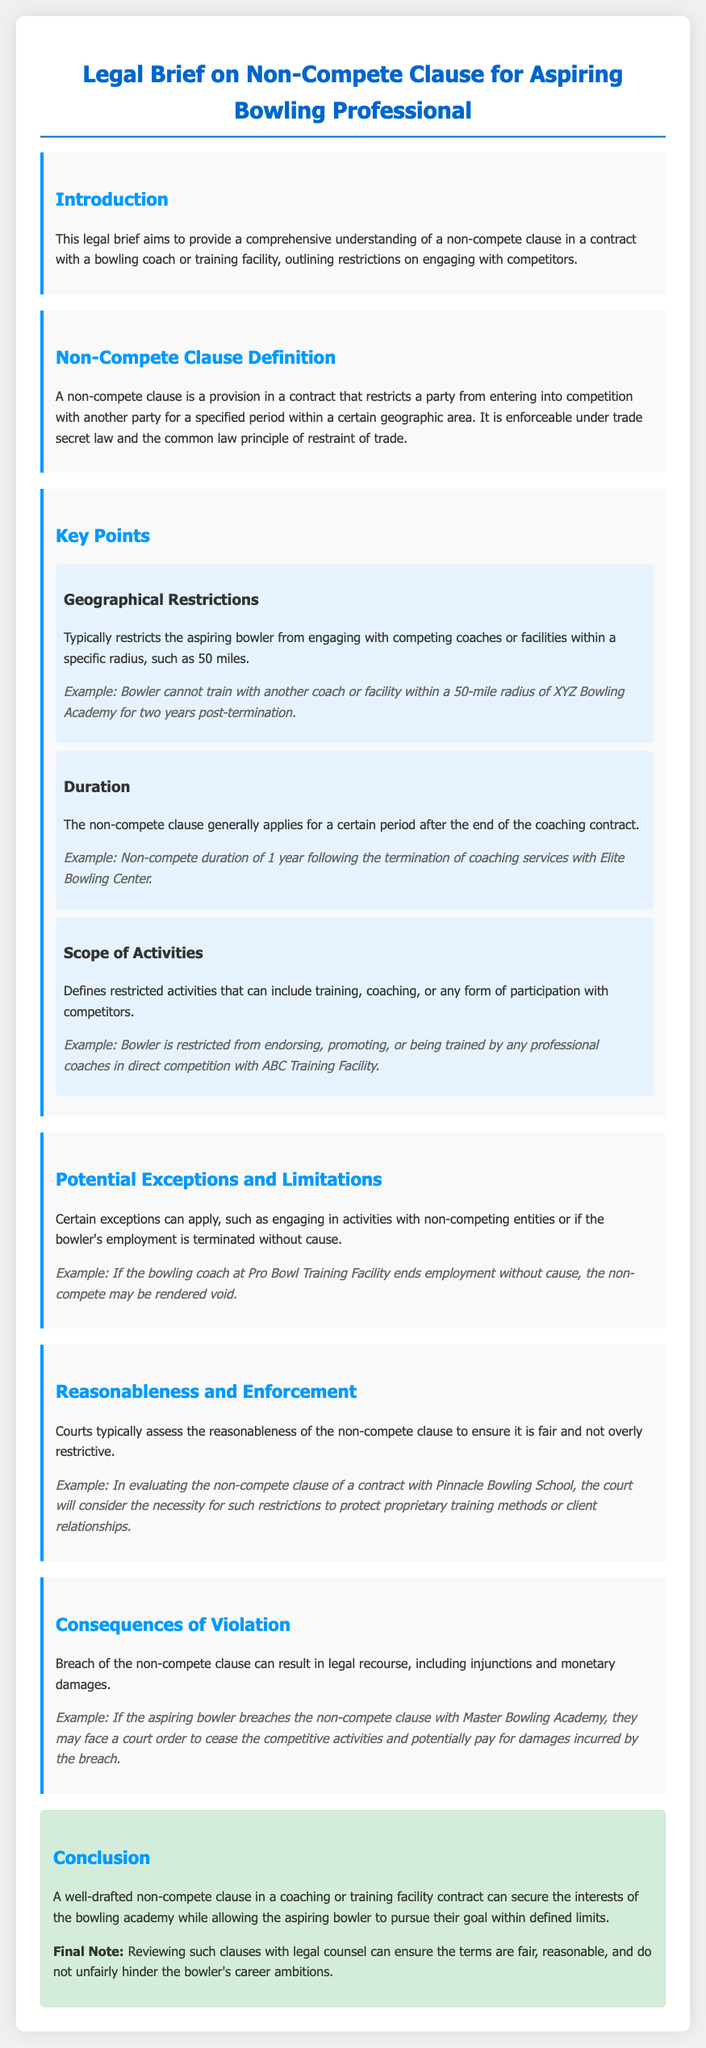What is a non-compete clause? A non-compete clause is a provision in a contract that restricts a party from entering into competition with another party for a specified period within a certain geographic area.
Answer: A provision in a contract What is the typical radius for geographical restrictions? Geographical restrictions typically limit the aspiring bowler from engaging with competing coaches or facilities within a specific radius.
Answer: 50 miles What is the duration of a non-compete clause after termination? The non-compete clause generally applies for a certain period after the end of the coaching contract.
Answer: 1 year What activities are restricted under the scope of activities? The scope of activities defines restricted activities that can include training, coaching, or any form of participation with competitors.
Answer: Training, coaching, participation What can happen in case of a breach of the non-compete clause? Breach of the non-compete clause can result in legal recourse, including injunctions and monetary damages.
Answer: Legal recourse What factors do courts consider for reasonableness? Courts assess the reasonableness of the non-compete clause to ensure it is fair and not overly restrictive.
Answer: Fairness and restrictions What should aspiring bowlers do before signing a non-compete clause? Reviewing such clauses with legal counsel can ensure the terms are fair, reasonable, and do not unfairly hinder the bowler's career ambitions.
Answer: Consult legal counsel 